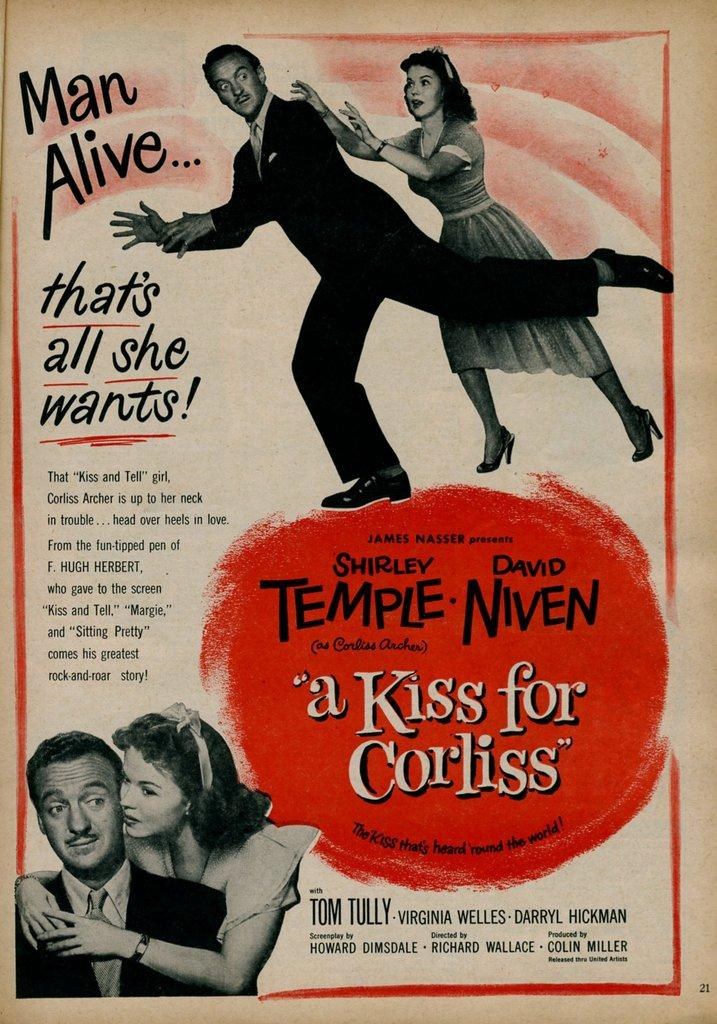<image>
Offer a succinct explanation of the picture presented. A movie poster for "A Kiss for Corliss" stars Shirley Temple. 